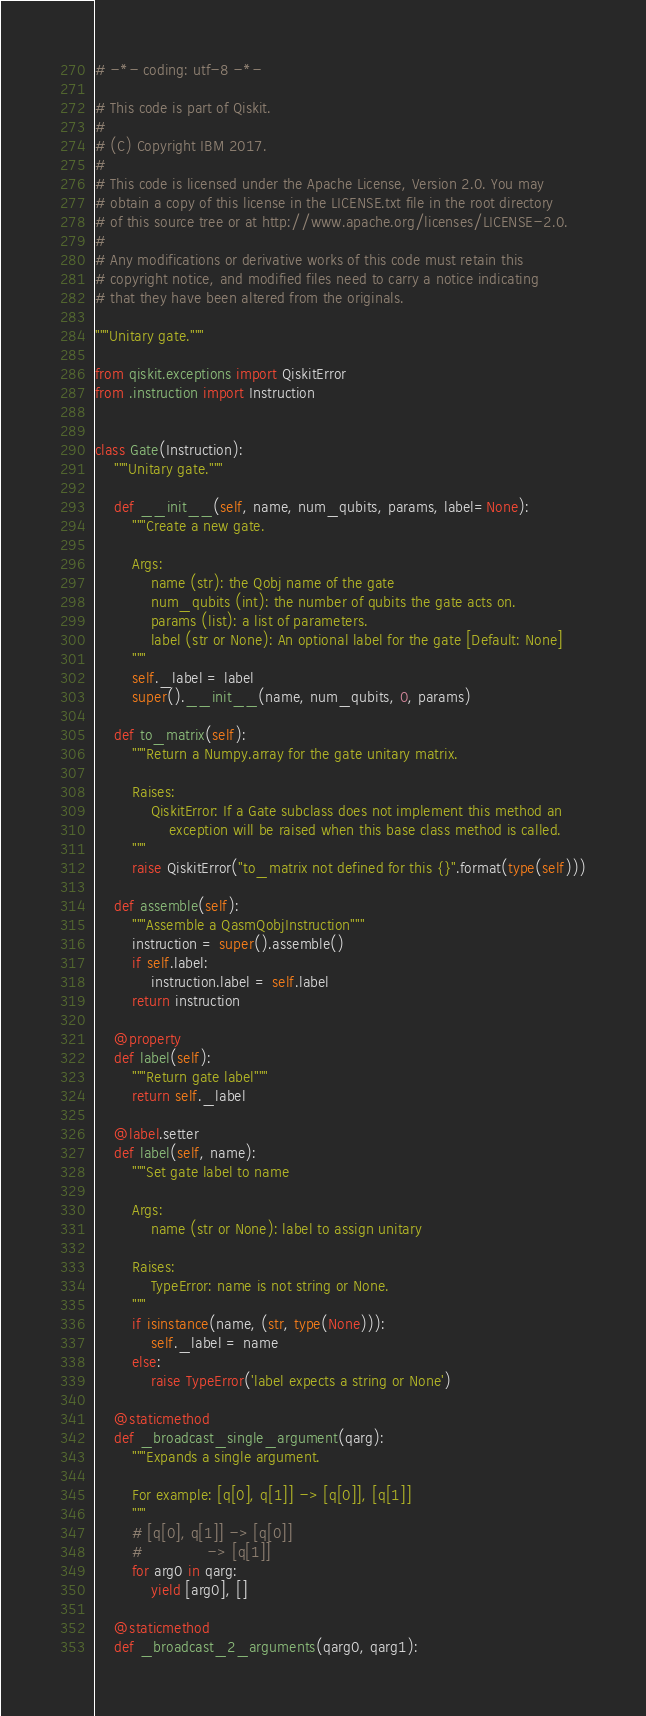Convert code to text. <code><loc_0><loc_0><loc_500><loc_500><_Python_># -*- coding: utf-8 -*-

# This code is part of Qiskit.
#
# (C) Copyright IBM 2017.
#
# This code is licensed under the Apache License, Version 2.0. You may
# obtain a copy of this license in the LICENSE.txt file in the root directory
# of this source tree or at http://www.apache.org/licenses/LICENSE-2.0.
#
# Any modifications or derivative works of this code must retain this
# copyright notice, and modified files need to carry a notice indicating
# that they have been altered from the originals.

"""Unitary gate."""

from qiskit.exceptions import QiskitError
from .instruction import Instruction


class Gate(Instruction):
    """Unitary gate."""

    def __init__(self, name, num_qubits, params, label=None):
        """Create a new gate.

        Args:
            name (str): the Qobj name of the gate
            num_qubits (int): the number of qubits the gate acts on.
            params (list): a list of parameters.
            label (str or None): An optional label for the gate [Default: None]
        """
        self._label = label
        super().__init__(name, num_qubits, 0, params)

    def to_matrix(self):
        """Return a Numpy.array for the gate unitary matrix.

        Raises:
            QiskitError: If a Gate subclass does not implement this method an
                exception will be raised when this base class method is called.
        """
        raise QiskitError("to_matrix not defined for this {}".format(type(self)))

    def assemble(self):
        """Assemble a QasmQobjInstruction"""
        instruction = super().assemble()
        if self.label:
            instruction.label = self.label
        return instruction

    @property
    def label(self):
        """Return gate label"""
        return self._label

    @label.setter
    def label(self, name):
        """Set gate label to name

        Args:
            name (str or None): label to assign unitary

        Raises:
            TypeError: name is not string or None.
        """
        if isinstance(name, (str, type(None))):
            self._label = name
        else:
            raise TypeError('label expects a string or None')

    @staticmethod
    def _broadcast_single_argument(qarg):
        """Expands a single argument.

        For example: [q[0], q[1]] -> [q[0]], [q[1]]
        """
        # [q[0], q[1]] -> [q[0]]
        #              -> [q[1]]
        for arg0 in qarg:
            yield [arg0], []

    @staticmethod
    def _broadcast_2_arguments(qarg0, qarg1):</code> 